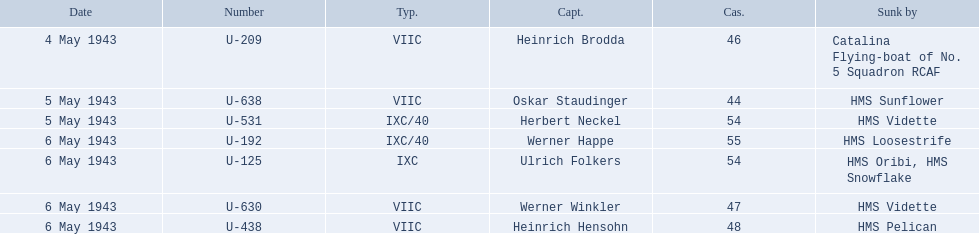Who are all of the captains? Heinrich Brodda, Oskar Staudinger, Herbert Neckel, Werner Happe, Ulrich Folkers, Werner Winkler, Heinrich Hensohn. What sunk each of the captains? Catalina Flying-boat of No. 5 Squadron RCAF, HMS Sunflower, HMS Vidette, HMS Loosestrife, HMS Oribi, HMS Snowflake, HMS Vidette, HMS Pelican. Which was sunk by the hms pelican? Heinrich Hensohn. 